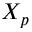<formula> <loc_0><loc_0><loc_500><loc_500>X _ { p }</formula> 